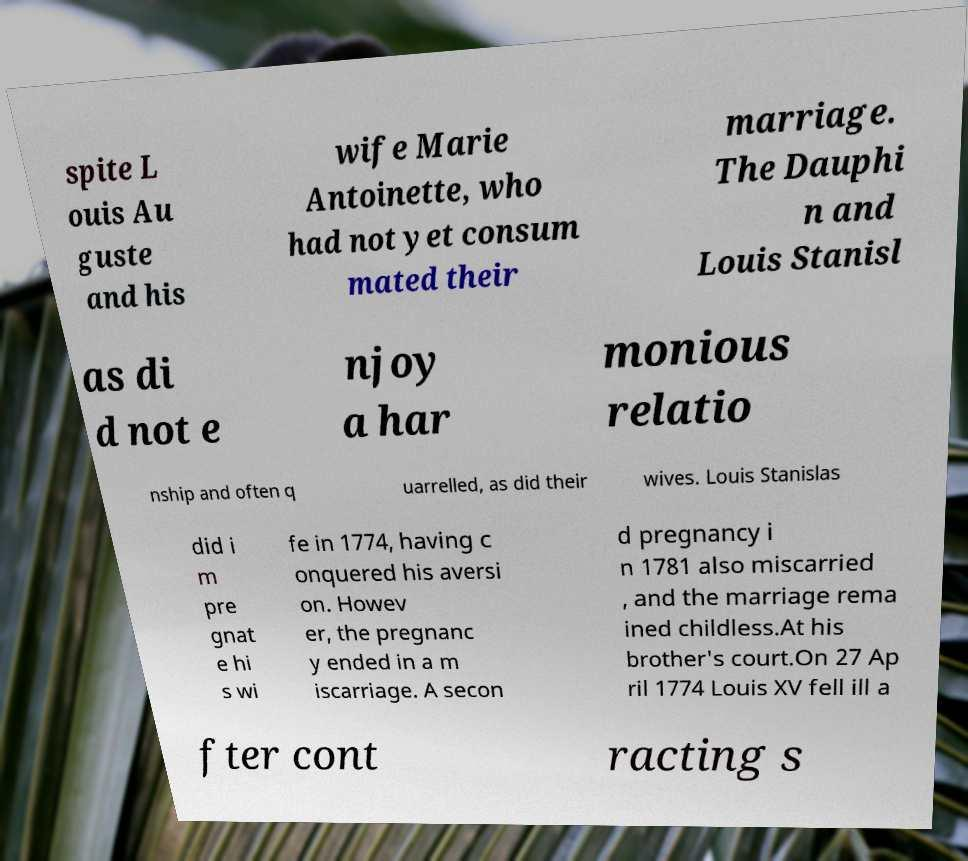Please identify and transcribe the text found in this image. spite L ouis Au guste and his wife Marie Antoinette, who had not yet consum mated their marriage. The Dauphi n and Louis Stanisl as di d not e njoy a har monious relatio nship and often q uarrelled, as did their wives. Louis Stanislas did i m pre gnat e hi s wi fe in 1774, having c onquered his aversi on. Howev er, the pregnanc y ended in a m iscarriage. A secon d pregnancy i n 1781 also miscarried , and the marriage rema ined childless.At his brother's court.On 27 Ap ril 1774 Louis XV fell ill a fter cont racting s 